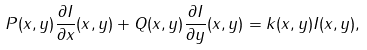<formula> <loc_0><loc_0><loc_500><loc_500>P ( x , y ) \frac { \partial I } { \partial x } ( x , y ) + Q ( x , y ) \frac { \partial I } { \partial y } ( x , y ) = k ( x , y ) I ( x , y ) ,</formula> 